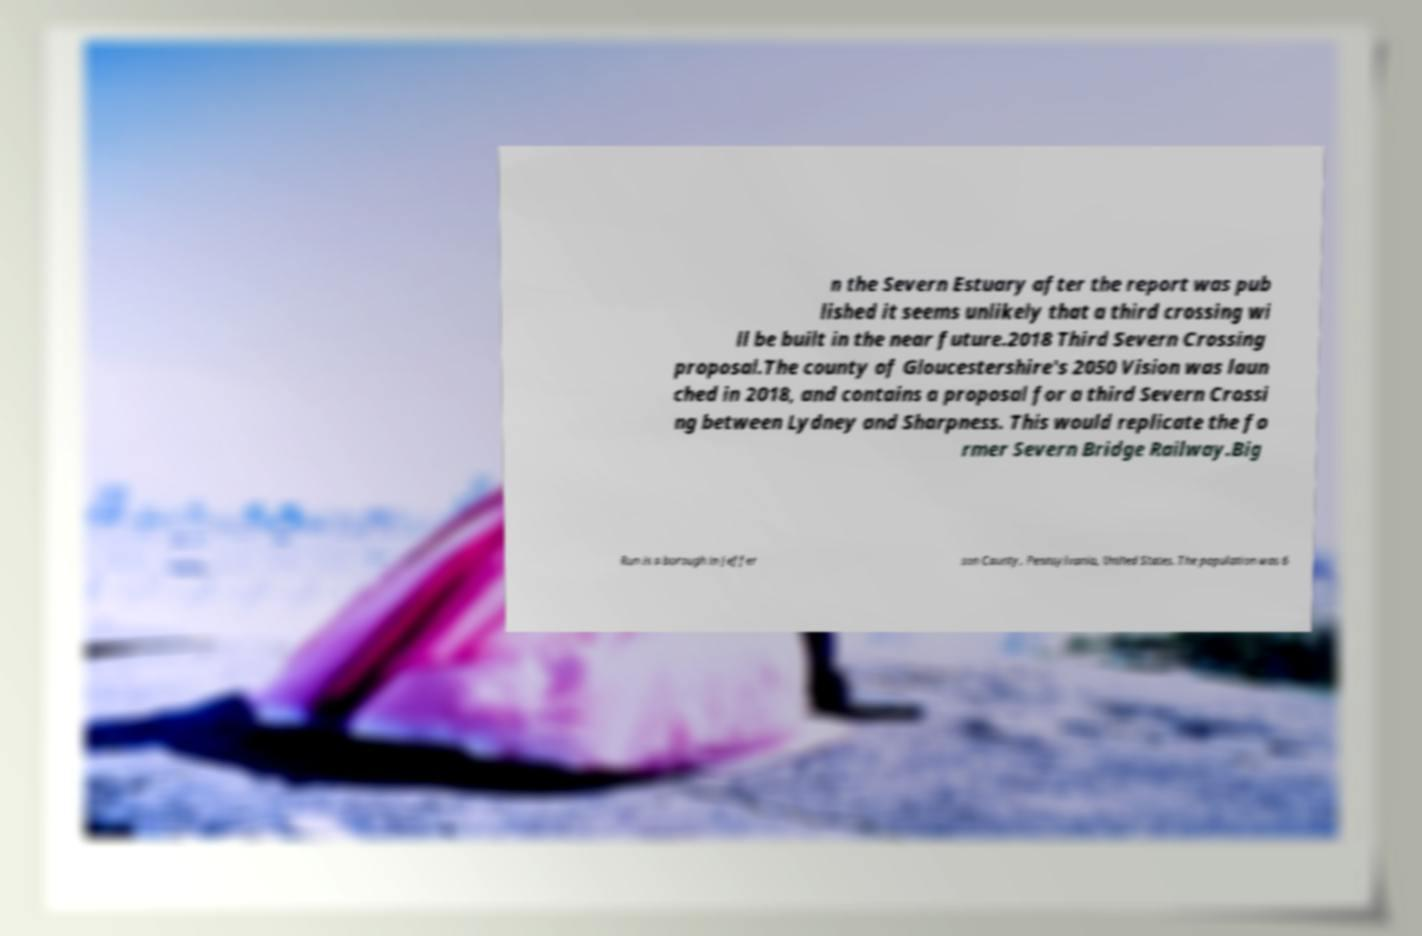Could you extract and type out the text from this image? n the Severn Estuary after the report was pub lished it seems unlikely that a third crossing wi ll be built in the near future.2018 Third Severn Crossing proposal.The county of Gloucestershire's 2050 Vision was laun ched in 2018, and contains a proposal for a third Severn Crossi ng between Lydney and Sharpness. This would replicate the fo rmer Severn Bridge Railway.Big Run is a borough in Jeffer son County, Pennsylvania, United States. The population was 6 